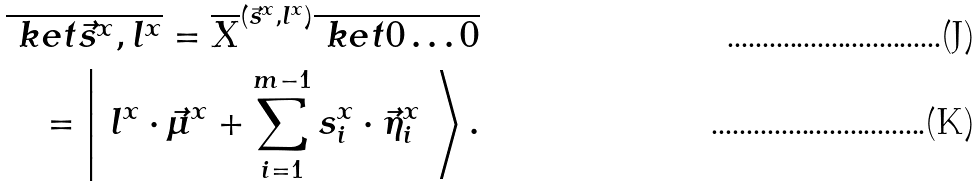Convert formula to latex. <formula><loc_0><loc_0><loc_500><loc_500>\overline { \ k e t { \vec { s } ^ { x } , l ^ { x } } } = \overline { X } ^ { ( \vec { s } ^ { x } , l ^ { x } ) } \overline { \ k e t { 0 \dots 0 } } \\ = \left | \ l ^ { x } \cdot \vec { \mu } ^ { x } + \sum _ { i = 1 } ^ { m - 1 } s ^ { x } _ { i } \cdot \vec { \eta } ^ { x } _ { i } \ \right \rangle .</formula> 